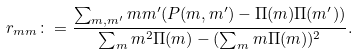Convert formula to latex. <formula><loc_0><loc_0><loc_500><loc_500>r _ { m m } \colon = \frac { \sum _ { m , m ^ { \prime } } m m ^ { \prime } ( P ( m , m ^ { \prime } ) - \Pi ( m ) \Pi ( m ^ { \prime } ) ) } { \sum _ { m } m ^ { 2 } \Pi ( m ) - ( \sum _ { m } m \Pi ( m ) ) ^ { 2 } } .</formula> 